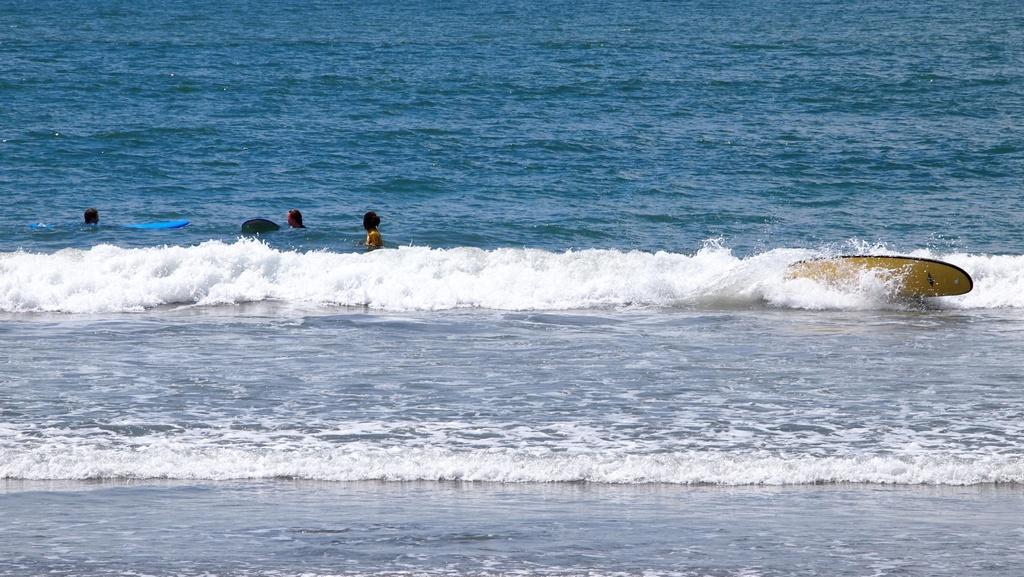Describe this image in one or two sentences. In this image, we can see some people in the water and a surfing board is on the water. 